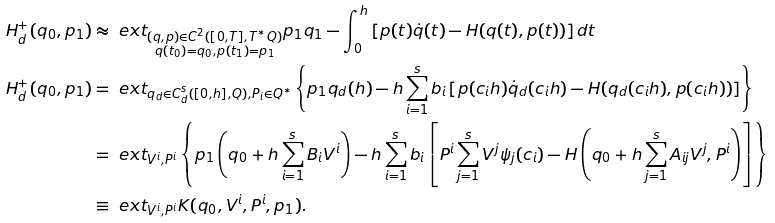Convert formula to latex. <formula><loc_0><loc_0><loc_500><loc_500>H _ { d } ^ { + } ( q _ { 0 } , p _ { 1 } ) & \approx \ e x t _ { \substack { ( q , p ) \in C ^ { 2 } ( [ 0 , T ] , T ^ { * } Q ) \\ q ( t _ { 0 } ) = q _ { 0 } , p ( t _ { 1 } ) = p _ { 1 } } } p _ { 1 } q _ { 1 } - \int _ { 0 } ^ { h } \left [ p ( t ) \dot { q } ( t ) - H ( q ( t ) , p ( t ) ) \right ] d t \\ H _ { d } ^ { + } ( q _ { 0 } , p _ { 1 } ) & = \ e x t _ { q _ { d } \in C _ { d } ^ { s } ( [ 0 , h ] , Q ) , P _ { i } \in Q ^ { * } } \left \{ p _ { 1 } q _ { d } ( h ) - h \sum _ { i = 1 } ^ { s } b _ { i } \left [ p ( c _ { i } h ) \dot { q } _ { d } ( c _ { i } h ) - H ( q _ { d } ( c _ { i } h ) , p ( c _ { i } h ) ) \right ] \right \} \\ & = \ e x t _ { V ^ { i } , P ^ { i } } \left \{ p _ { 1 } \left ( q _ { 0 } + h \sum _ { i = 1 } ^ { s } B _ { i } V ^ { i } \right ) - h \sum _ { i = 1 } ^ { s } b _ { i } \left [ P ^ { i } \sum _ { j = 1 } ^ { s } V ^ { j } \psi _ { j } ( c _ { i } ) - H \left ( q _ { 0 } + h \sum _ { j = 1 } ^ { s } A _ { i j } V ^ { j } , P ^ { i } \right ) \right ] \right \} \\ & \equiv \ e x t _ { V ^ { i } , P ^ { i } } K ( q _ { 0 } , V ^ { i } , P ^ { i } , p _ { 1 } ) .</formula> 